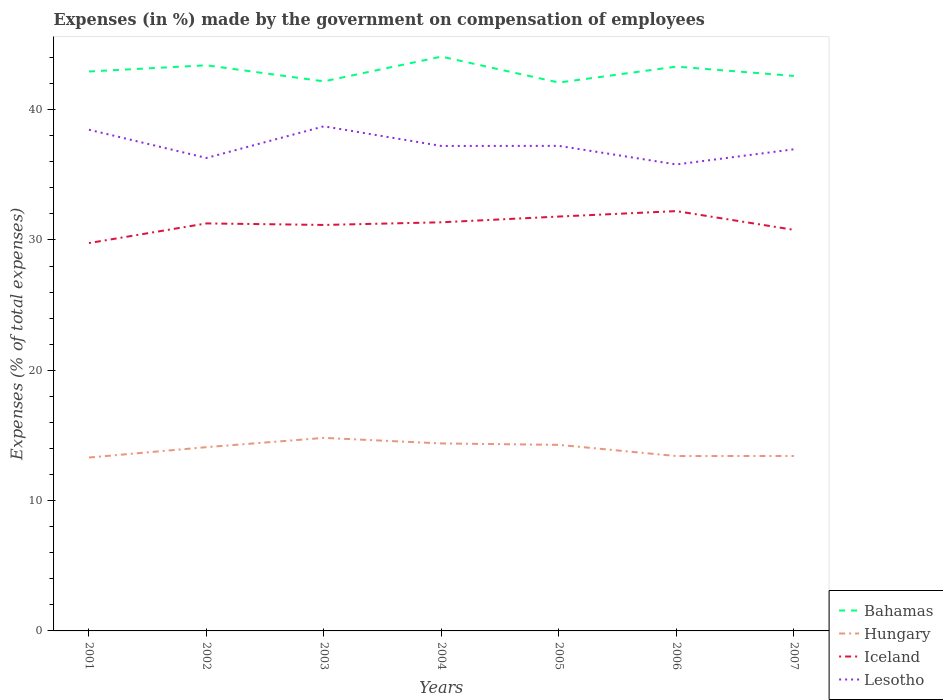Does the line corresponding to Bahamas intersect with the line corresponding to Hungary?
Provide a short and direct response. No. Across all years, what is the maximum percentage of expenses made by the government on compensation of employees in Lesotho?
Your answer should be very brief. 35.8. What is the total percentage of expenses made by the government on compensation of employees in Hungary in the graph?
Ensure brevity in your answer.  0.68. What is the difference between the highest and the second highest percentage of expenses made by the government on compensation of employees in Iceland?
Offer a very short reply. 2.45. What is the difference between the highest and the lowest percentage of expenses made by the government on compensation of employees in Lesotho?
Make the answer very short. 2. How many lines are there?
Provide a succinct answer. 4. How many years are there in the graph?
Your response must be concise. 7. What is the title of the graph?
Make the answer very short. Expenses (in %) made by the government on compensation of employees. Does "China" appear as one of the legend labels in the graph?
Make the answer very short. No. What is the label or title of the Y-axis?
Provide a succinct answer. Expenses (% of total expenses). What is the Expenses (% of total expenses) of Bahamas in 2001?
Provide a short and direct response. 42.93. What is the Expenses (% of total expenses) of Hungary in 2001?
Make the answer very short. 13.31. What is the Expenses (% of total expenses) in Iceland in 2001?
Ensure brevity in your answer.  29.76. What is the Expenses (% of total expenses) of Lesotho in 2001?
Your answer should be compact. 38.46. What is the Expenses (% of total expenses) of Bahamas in 2002?
Your response must be concise. 43.41. What is the Expenses (% of total expenses) in Hungary in 2002?
Keep it short and to the point. 14.1. What is the Expenses (% of total expenses) in Iceland in 2002?
Your answer should be compact. 31.27. What is the Expenses (% of total expenses) of Lesotho in 2002?
Your answer should be very brief. 36.29. What is the Expenses (% of total expenses) of Bahamas in 2003?
Give a very brief answer. 42.17. What is the Expenses (% of total expenses) of Hungary in 2003?
Give a very brief answer. 14.81. What is the Expenses (% of total expenses) of Iceland in 2003?
Give a very brief answer. 31.15. What is the Expenses (% of total expenses) of Lesotho in 2003?
Your answer should be very brief. 38.72. What is the Expenses (% of total expenses) of Bahamas in 2004?
Make the answer very short. 44.07. What is the Expenses (% of total expenses) in Hungary in 2004?
Your response must be concise. 14.39. What is the Expenses (% of total expenses) of Iceland in 2004?
Provide a short and direct response. 31.36. What is the Expenses (% of total expenses) in Lesotho in 2004?
Provide a succinct answer. 37.21. What is the Expenses (% of total expenses) in Bahamas in 2005?
Your response must be concise. 42.08. What is the Expenses (% of total expenses) of Hungary in 2005?
Keep it short and to the point. 14.28. What is the Expenses (% of total expenses) in Iceland in 2005?
Your response must be concise. 31.8. What is the Expenses (% of total expenses) of Lesotho in 2005?
Ensure brevity in your answer.  37.22. What is the Expenses (% of total expenses) of Bahamas in 2006?
Your answer should be very brief. 43.3. What is the Expenses (% of total expenses) in Hungary in 2006?
Your response must be concise. 13.42. What is the Expenses (% of total expenses) in Iceland in 2006?
Your answer should be very brief. 32.21. What is the Expenses (% of total expenses) in Lesotho in 2006?
Ensure brevity in your answer.  35.8. What is the Expenses (% of total expenses) in Bahamas in 2007?
Your answer should be very brief. 42.59. What is the Expenses (% of total expenses) in Hungary in 2007?
Provide a short and direct response. 13.43. What is the Expenses (% of total expenses) of Iceland in 2007?
Your answer should be very brief. 30.78. What is the Expenses (% of total expenses) in Lesotho in 2007?
Offer a very short reply. 36.96. Across all years, what is the maximum Expenses (% of total expenses) of Bahamas?
Offer a very short reply. 44.07. Across all years, what is the maximum Expenses (% of total expenses) in Hungary?
Your answer should be compact. 14.81. Across all years, what is the maximum Expenses (% of total expenses) in Iceland?
Your answer should be very brief. 32.21. Across all years, what is the maximum Expenses (% of total expenses) in Lesotho?
Your response must be concise. 38.72. Across all years, what is the minimum Expenses (% of total expenses) of Bahamas?
Your answer should be very brief. 42.08. Across all years, what is the minimum Expenses (% of total expenses) of Hungary?
Offer a very short reply. 13.31. Across all years, what is the minimum Expenses (% of total expenses) of Iceland?
Make the answer very short. 29.76. Across all years, what is the minimum Expenses (% of total expenses) of Lesotho?
Ensure brevity in your answer.  35.8. What is the total Expenses (% of total expenses) of Bahamas in the graph?
Ensure brevity in your answer.  300.55. What is the total Expenses (% of total expenses) in Hungary in the graph?
Provide a short and direct response. 97.73. What is the total Expenses (% of total expenses) in Iceland in the graph?
Ensure brevity in your answer.  218.34. What is the total Expenses (% of total expenses) of Lesotho in the graph?
Ensure brevity in your answer.  260.66. What is the difference between the Expenses (% of total expenses) of Bahamas in 2001 and that in 2002?
Make the answer very short. -0.48. What is the difference between the Expenses (% of total expenses) of Hungary in 2001 and that in 2002?
Provide a short and direct response. -0.8. What is the difference between the Expenses (% of total expenses) in Iceland in 2001 and that in 2002?
Provide a short and direct response. -1.51. What is the difference between the Expenses (% of total expenses) in Lesotho in 2001 and that in 2002?
Provide a succinct answer. 2.17. What is the difference between the Expenses (% of total expenses) of Bahamas in 2001 and that in 2003?
Make the answer very short. 0.76. What is the difference between the Expenses (% of total expenses) of Hungary in 2001 and that in 2003?
Your answer should be compact. -1.51. What is the difference between the Expenses (% of total expenses) of Iceland in 2001 and that in 2003?
Keep it short and to the point. -1.39. What is the difference between the Expenses (% of total expenses) of Lesotho in 2001 and that in 2003?
Make the answer very short. -0.26. What is the difference between the Expenses (% of total expenses) in Bahamas in 2001 and that in 2004?
Provide a succinct answer. -1.14. What is the difference between the Expenses (% of total expenses) in Hungary in 2001 and that in 2004?
Offer a very short reply. -1.08. What is the difference between the Expenses (% of total expenses) in Iceland in 2001 and that in 2004?
Your answer should be very brief. -1.59. What is the difference between the Expenses (% of total expenses) of Lesotho in 2001 and that in 2004?
Offer a terse response. 1.25. What is the difference between the Expenses (% of total expenses) in Bahamas in 2001 and that in 2005?
Keep it short and to the point. 0.85. What is the difference between the Expenses (% of total expenses) of Hungary in 2001 and that in 2005?
Keep it short and to the point. -0.97. What is the difference between the Expenses (% of total expenses) in Iceland in 2001 and that in 2005?
Ensure brevity in your answer.  -2.04. What is the difference between the Expenses (% of total expenses) of Lesotho in 2001 and that in 2005?
Make the answer very short. 1.24. What is the difference between the Expenses (% of total expenses) of Bahamas in 2001 and that in 2006?
Ensure brevity in your answer.  -0.37. What is the difference between the Expenses (% of total expenses) of Hungary in 2001 and that in 2006?
Make the answer very short. -0.11. What is the difference between the Expenses (% of total expenses) in Iceland in 2001 and that in 2006?
Keep it short and to the point. -2.45. What is the difference between the Expenses (% of total expenses) of Lesotho in 2001 and that in 2006?
Your answer should be compact. 2.67. What is the difference between the Expenses (% of total expenses) in Bahamas in 2001 and that in 2007?
Ensure brevity in your answer.  0.34. What is the difference between the Expenses (% of total expenses) of Hungary in 2001 and that in 2007?
Provide a succinct answer. -0.12. What is the difference between the Expenses (% of total expenses) in Iceland in 2001 and that in 2007?
Keep it short and to the point. -1.01. What is the difference between the Expenses (% of total expenses) of Lesotho in 2001 and that in 2007?
Keep it short and to the point. 1.5. What is the difference between the Expenses (% of total expenses) in Bahamas in 2002 and that in 2003?
Give a very brief answer. 1.23. What is the difference between the Expenses (% of total expenses) in Hungary in 2002 and that in 2003?
Offer a terse response. -0.71. What is the difference between the Expenses (% of total expenses) of Iceland in 2002 and that in 2003?
Offer a terse response. 0.12. What is the difference between the Expenses (% of total expenses) in Lesotho in 2002 and that in 2003?
Provide a succinct answer. -2.43. What is the difference between the Expenses (% of total expenses) of Bahamas in 2002 and that in 2004?
Your response must be concise. -0.66. What is the difference between the Expenses (% of total expenses) in Hungary in 2002 and that in 2004?
Offer a very short reply. -0.29. What is the difference between the Expenses (% of total expenses) of Iceland in 2002 and that in 2004?
Provide a succinct answer. -0.09. What is the difference between the Expenses (% of total expenses) in Lesotho in 2002 and that in 2004?
Make the answer very short. -0.92. What is the difference between the Expenses (% of total expenses) of Bahamas in 2002 and that in 2005?
Your answer should be very brief. 1.33. What is the difference between the Expenses (% of total expenses) of Hungary in 2002 and that in 2005?
Provide a short and direct response. -0.18. What is the difference between the Expenses (% of total expenses) in Iceland in 2002 and that in 2005?
Offer a very short reply. -0.53. What is the difference between the Expenses (% of total expenses) in Lesotho in 2002 and that in 2005?
Ensure brevity in your answer.  -0.93. What is the difference between the Expenses (% of total expenses) in Bahamas in 2002 and that in 2006?
Your response must be concise. 0.1. What is the difference between the Expenses (% of total expenses) in Hungary in 2002 and that in 2006?
Make the answer very short. 0.68. What is the difference between the Expenses (% of total expenses) in Iceland in 2002 and that in 2006?
Offer a very short reply. -0.94. What is the difference between the Expenses (% of total expenses) of Lesotho in 2002 and that in 2006?
Your response must be concise. 0.5. What is the difference between the Expenses (% of total expenses) of Bahamas in 2002 and that in 2007?
Your answer should be very brief. 0.82. What is the difference between the Expenses (% of total expenses) in Hungary in 2002 and that in 2007?
Your answer should be compact. 0.68. What is the difference between the Expenses (% of total expenses) in Iceland in 2002 and that in 2007?
Provide a short and direct response. 0.49. What is the difference between the Expenses (% of total expenses) of Lesotho in 2002 and that in 2007?
Ensure brevity in your answer.  -0.67. What is the difference between the Expenses (% of total expenses) in Bahamas in 2003 and that in 2004?
Your response must be concise. -1.9. What is the difference between the Expenses (% of total expenses) of Hungary in 2003 and that in 2004?
Your response must be concise. 0.43. What is the difference between the Expenses (% of total expenses) in Iceland in 2003 and that in 2004?
Make the answer very short. -0.2. What is the difference between the Expenses (% of total expenses) of Lesotho in 2003 and that in 2004?
Make the answer very short. 1.51. What is the difference between the Expenses (% of total expenses) of Bahamas in 2003 and that in 2005?
Your answer should be compact. 0.09. What is the difference between the Expenses (% of total expenses) of Hungary in 2003 and that in 2005?
Keep it short and to the point. 0.54. What is the difference between the Expenses (% of total expenses) in Iceland in 2003 and that in 2005?
Provide a short and direct response. -0.65. What is the difference between the Expenses (% of total expenses) in Lesotho in 2003 and that in 2005?
Make the answer very short. 1.5. What is the difference between the Expenses (% of total expenses) of Bahamas in 2003 and that in 2006?
Your response must be concise. -1.13. What is the difference between the Expenses (% of total expenses) in Hungary in 2003 and that in 2006?
Offer a very short reply. 1.4. What is the difference between the Expenses (% of total expenses) in Iceland in 2003 and that in 2006?
Make the answer very short. -1.06. What is the difference between the Expenses (% of total expenses) in Lesotho in 2003 and that in 2006?
Your response must be concise. 2.93. What is the difference between the Expenses (% of total expenses) of Bahamas in 2003 and that in 2007?
Give a very brief answer. -0.42. What is the difference between the Expenses (% of total expenses) of Hungary in 2003 and that in 2007?
Your answer should be compact. 1.39. What is the difference between the Expenses (% of total expenses) in Iceland in 2003 and that in 2007?
Offer a terse response. 0.38. What is the difference between the Expenses (% of total expenses) of Lesotho in 2003 and that in 2007?
Provide a short and direct response. 1.76. What is the difference between the Expenses (% of total expenses) of Bahamas in 2004 and that in 2005?
Provide a short and direct response. 1.99. What is the difference between the Expenses (% of total expenses) in Hungary in 2004 and that in 2005?
Offer a terse response. 0.11. What is the difference between the Expenses (% of total expenses) in Iceland in 2004 and that in 2005?
Provide a succinct answer. -0.44. What is the difference between the Expenses (% of total expenses) in Lesotho in 2004 and that in 2005?
Offer a terse response. -0.01. What is the difference between the Expenses (% of total expenses) of Bahamas in 2004 and that in 2006?
Your response must be concise. 0.77. What is the difference between the Expenses (% of total expenses) in Hungary in 2004 and that in 2006?
Make the answer very short. 0.97. What is the difference between the Expenses (% of total expenses) in Iceland in 2004 and that in 2006?
Keep it short and to the point. -0.86. What is the difference between the Expenses (% of total expenses) in Lesotho in 2004 and that in 2006?
Give a very brief answer. 1.42. What is the difference between the Expenses (% of total expenses) in Bahamas in 2004 and that in 2007?
Your answer should be very brief. 1.48. What is the difference between the Expenses (% of total expenses) in Hungary in 2004 and that in 2007?
Offer a terse response. 0.96. What is the difference between the Expenses (% of total expenses) in Iceland in 2004 and that in 2007?
Give a very brief answer. 0.58. What is the difference between the Expenses (% of total expenses) in Lesotho in 2004 and that in 2007?
Ensure brevity in your answer.  0.26. What is the difference between the Expenses (% of total expenses) of Bahamas in 2005 and that in 2006?
Offer a very short reply. -1.22. What is the difference between the Expenses (% of total expenses) of Hungary in 2005 and that in 2006?
Ensure brevity in your answer.  0.86. What is the difference between the Expenses (% of total expenses) in Iceland in 2005 and that in 2006?
Offer a very short reply. -0.42. What is the difference between the Expenses (% of total expenses) in Lesotho in 2005 and that in 2006?
Keep it short and to the point. 1.43. What is the difference between the Expenses (% of total expenses) in Bahamas in 2005 and that in 2007?
Your answer should be very brief. -0.51. What is the difference between the Expenses (% of total expenses) of Hungary in 2005 and that in 2007?
Provide a succinct answer. 0.85. What is the difference between the Expenses (% of total expenses) in Iceland in 2005 and that in 2007?
Provide a short and direct response. 1.02. What is the difference between the Expenses (% of total expenses) of Lesotho in 2005 and that in 2007?
Offer a terse response. 0.26. What is the difference between the Expenses (% of total expenses) of Bahamas in 2006 and that in 2007?
Provide a short and direct response. 0.72. What is the difference between the Expenses (% of total expenses) of Hungary in 2006 and that in 2007?
Your answer should be very brief. -0.01. What is the difference between the Expenses (% of total expenses) of Iceland in 2006 and that in 2007?
Keep it short and to the point. 1.44. What is the difference between the Expenses (% of total expenses) in Lesotho in 2006 and that in 2007?
Offer a terse response. -1.16. What is the difference between the Expenses (% of total expenses) of Bahamas in 2001 and the Expenses (% of total expenses) of Hungary in 2002?
Provide a succinct answer. 28.83. What is the difference between the Expenses (% of total expenses) in Bahamas in 2001 and the Expenses (% of total expenses) in Iceland in 2002?
Provide a short and direct response. 11.66. What is the difference between the Expenses (% of total expenses) of Bahamas in 2001 and the Expenses (% of total expenses) of Lesotho in 2002?
Offer a very short reply. 6.64. What is the difference between the Expenses (% of total expenses) of Hungary in 2001 and the Expenses (% of total expenses) of Iceland in 2002?
Offer a terse response. -17.97. What is the difference between the Expenses (% of total expenses) of Hungary in 2001 and the Expenses (% of total expenses) of Lesotho in 2002?
Make the answer very short. -22.99. What is the difference between the Expenses (% of total expenses) of Iceland in 2001 and the Expenses (% of total expenses) of Lesotho in 2002?
Your answer should be very brief. -6.53. What is the difference between the Expenses (% of total expenses) of Bahamas in 2001 and the Expenses (% of total expenses) of Hungary in 2003?
Your answer should be compact. 28.12. What is the difference between the Expenses (% of total expenses) of Bahamas in 2001 and the Expenses (% of total expenses) of Iceland in 2003?
Your response must be concise. 11.78. What is the difference between the Expenses (% of total expenses) of Bahamas in 2001 and the Expenses (% of total expenses) of Lesotho in 2003?
Provide a short and direct response. 4.21. What is the difference between the Expenses (% of total expenses) in Hungary in 2001 and the Expenses (% of total expenses) in Iceland in 2003?
Offer a very short reply. -17.85. What is the difference between the Expenses (% of total expenses) of Hungary in 2001 and the Expenses (% of total expenses) of Lesotho in 2003?
Offer a terse response. -25.42. What is the difference between the Expenses (% of total expenses) in Iceland in 2001 and the Expenses (% of total expenses) in Lesotho in 2003?
Provide a succinct answer. -8.96. What is the difference between the Expenses (% of total expenses) of Bahamas in 2001 and the Expenses (% of total expenses) of Hungary in 2004?
Give a very brief answer. 28.54. What is the difference between the Expenses (% of total expenses) in Bahamas in 2001 and the Expenses (% of total expenses) in Iceland in 2004?
Provide a succinct answer. 11.57. What is the difference between the Expenses (% of total expenses) in Bahamas in 2001 and the Expenses (% of total expenses) in Lesotho in 2004?
Keep it short and to the point. 5.72. What is the difference between the Expenses (% of total expenses) in Hungary in 2001 and the Expenses (% of total expenses) in Iceland in 2004?
Give a very brief answer. -18.05. What is the difference between the Expenses (% of total expenses) in Hungary in 2001 and the Expenses (% of total expenses) in Lesotho in 2004?
Keep it short and to the point. -23.91. What is the difference between the Expenses (% of total expenses) in Iceland in 2001 and the Expenses (% of total expenses) in Lesotho in 2004?
Your response must be concise. -7.45. What is the difference between the Expenses (% of total expenses) of Bahamas in 2001 and the Expenses (% of total expenses) of Hungary in 2005?
Your answer should be compact. 28.65. What is the difference between the Expenses (% of total expenses) of Bahamas in 2001 and the Expenses (% of total expenses) of Iceland in 2005?
Offer a very short reply. 11.13. What is the difference between the Expenses (% of total expenses) in Bahamas in 2001 and the Expenses (% of total expenses) in Lesotho in 2005?
Provide a short and direct response. 5.71. What is the difference between the Expenses (% of total expenses) of Hungary in 2001 and the Expenses (% of total expenses) of Iceland in 2005?
Keep it short and to the point. -18.49. What is the difference between the Expenses (% of total expenses) in Hungary in 2001 and the Expenses (% of total expenses) in Lesotho in 2005?
Offer a terse response. -23.92. What is the difference between the Expenses (% of total expenses) in Iceland in 2001 and the Expenses (% of total expenses) in Lesotho in 2005?
Ensure brevity in your answer.  -7.46. What is the difference between the Expenses (% of total expenses) of Bahamas in 2001 and the Expenses (% of total expenses) of Hungary in 2006?
Provide a succinct answer. 29.51. What is the difference between the Expenses (% of total expenses) in Bahamas in 2001 and the Expenses (% of total expenses) in Iceland in 2006?
Your answer should be compact. 10.72. What is the difference between the Expenses (% of total expenses) in Bahamas in 2001 and the Expenses (% of total expenses) in Lesotho in 2006?
Make the answer very short. 7.13. What is the difference between the Expenses (% of total expenses) of Hungary in 2001 and the Expenses (% of total expenses) of Iceland in 2006?
Ensure brevity in your answer.  -18.91. What is the difference between the Expenses (% of total expenses) in Hungary in 2001 and the Expenses (% of total expenses) in Lesotho in 2006?
Ensure brevity in your answer.  -22.49. What is the difference between the Expenses (% of total expenses) in Iceland in 2001 and the Expenses (% of total expenses) in Lesotho in 2006?
Your answer should be very brief. -6.03. What is the difference between the Expenses (% of total expenses) in Bahamas in 2001 and the Expenses (% of total expenses) in Hungary in 2007?
Provide a succinct answer. 29.5. What is the difference between the Expenses (% of total expenses) in Bahamas in 2001 and the Expenses (% of total expenses) in Iceland in 2007?
Make the answer very short. 12.15. What is the difference between the Expenses (% of total expenses) in Bahamas in 2001 and the Expenses (% of total expenses) in Lesotho in 2007?
Make the answer very short. 5.97. What is the difference between the Expenses (% of total expenses) in Hungary in 2001 and the Expenses (% of total expenses) in Iceland in 2007?
Give a very brief answer. -17.47. What is the difference between the Expenses (% of total expenses) of Hungary in 2001 and the Expenses (% of total expenses) of Lesotho in 2007?
Provide a succinct answer. -23.65. What is the difference between the Expenses (% of total expenses) in Iceland in 2001 and the Expenses (% of total expenses) in Lesotho in 2007?
Your response must be concise. -7.2. What is the difference between the Expenses (% of total expenses) of Bahamas in 2002 and the Expenses (% of total expenses) of Hungary in 2003?
Make the answer very short. 28.59. What is the difference between the Expenses (% of total expenses) of Bahamas in 2002 and the Expenses (% of total expenses) of Iceland in 2003?
Keep it short and to the point. 12.25. What is the difference between the Expenses (% of total expenses) in Bahamas in 2002 and the Expenses (% of total expenses) in Lesotho in 2003?
Your answer should be compact. 4.68. What is the difference between the Expenses (% of total expenses) in Hungary in 2002 and the Expenses (% of total expenses) in Iceland in 2003?
Your answer should be compact. -17.05. What is the difference between the Expenses (% of total expenses) of Hungary in 2002 and the Expenses (% of total expenses) of Lesotho in 2003?
Provide a succinct answer. -24.62. What is the difference between the Expenses (% of total expenses) in Iceland in 2002 and the Expenses (% of total expenses) in Lesotho in 2003?
Your answer should be compact. -7.45. What is the difference between the Expenses (% of total expenses) of Bahamas in 2002 and the Expenses (% of total expenses) of Hungary in 2004?
Offer a terse response. 29.02. What is the difference between the Expenses (% of total expenses) of Bahamas in 2002 and the Expenses (% of total expenses) of Iceland in 2004?
Offer a very short reply. 12.05. What is the difference between the Expenses (% of total expenses) of Bahamas in 2002 and the Expenses (% of total expenses) of Lesotho in 2004?
Your answer should be very brief. 6.19. What is the difference between the Expenses (% of total expenses) in Hungary in 2002 and the Expenses (% of total expenses) in Iceland in 2004?
Give a very brief answer. -17.26. What is the difference between the Expenses (% of total expenses) in Hungary in 2002 and the Expenses (% of total expenses) in Lesotho in 2004?
Your answer should be very brief. -23.11. What is the difference between the Expenses (% of total expenses) in Iceland in 2002 and the Expenses (% of total expenses) in Lesotho in 2004?
Provide a short and direct response. -5.94. What is the difference between the Expenses (% of total expenses) in Bahamas in 2002 and the Expenses (% of total expenses) in Hungary in 2005?
Make the answer very short. 29.13. What is the difference between the Expenses (% of total expenses) in Bahamas in 2002 and the Expenses (% of total expenses) in Iceland in 2005?
Your answer should be very brief. 11.61. What is the difference between the Expenses (% of total expenses) of Bahamas in 2002 and the Expenses (% of total expenses) of Lesotho in 2005?
Provide a succinct answer. 6.18. What is the difference between the Expenses (% of total expenses) in Hungary in 2002 and the Expenses (% of total expenses) in Iceland in 2005?
Your answer should be very brief. -17.7. What is the difference between the Expenses (% of total expenses) in Hungary in 2002 and the Expenses (% of total expenses) in Lesotho in 2005?
Give a very brief answer. -23.12. What is the difference between the Expenses (% of total expenses) of Iceland in 2002 and the Expenses (% of total expenses) of Lesotho in 2005?
Make the answer very short. -5.95. What is the difference between the Expenses (% of total expenses) of Bahamas in 2002 and the Expenses (% of total expenses) of Hungary in 2006?
Offer a terse response. 29.99. What is the difference between the Expenses (% of total expenses) of Bahamas in 2002 and the Expenses (% of total expenses) of Iceland in 2006?
Your answer should be very brief. 11.19. What is the difference between the Expenses (% of total expenses) of Bahamas in 2002 and the Expenses (% of total expenses) of Lesotho in 2006?
Give a very brief answer. 7.61. What is the difference between the Expenses (% of total expenses) in Hungary in 2002 and the Expenses (% of total expenses) in Iceland in 2006?
Provide a succinct answer. -18.11. What is the difference between the Expenses (% of total expenses) in Hungary in 2002 and the Expenses (% of total expenses) in Lesotho in 2006?
Provide a short and direct response. -21.69. What is the difference between the Expenses (% of total expenses) of Iceland in 2002 and the Expenses (% of total expenses) of Lesotho in 2006?
Ensure brevity in your answer.  -4.52. What is the difference between the Expenses (% of total expenses) in Bahamas in 2002 and the Expenses (% of total expenses) in Hungary in 2007?
Your response must be concise. 29.98. What is the difference between the Expenses (% of total expenses) of Bahamas in 2002 and the Expenses (% of total expenses) of Iceland in 2007?
Provide a succinct answer. 12.63. What is the difference between the Expenses (% of total expenses) of Bahamas in 2002 and the Expenses (% of total expenses) of Lesotho in 2007?
Make the answer very short. 6.45. What is the difference between the Expenses (% of total expenses) of Hungary in 2002 and the Expenses (% of total expenses) of Iceland in 2007?
Offer a very short reply. -16.68. What is the difference between the Expenses (% of total expenses) in Hungary in 2002 and the Expenses (% of total expenses) in Lesotho in 2007?
Give a very brief answer. -22.86. What is the difference between the Expenses (% of total expenses) of Iceland in 2002 and the Expenses (% of total expenses) of Lesotho in 2007?
Provide a short and direct response. -5.69. What is the difference between the Expenses (% of total expenses) in Bahamas in 2003 and the Expenses (% of total expenses) in Hungary in 2004?
Your answer should be very brief. 27.79. What is the difference between the Expenses (% of total expenses) of Bahamas in 2003 and the Expenses (% of total expenses) of Iceland in 2004?
Your answer should be compact. 10.82. What is the difference between the Expenses (% of total expenses) in Bahamas in 2003 and the Expenses (% of total expenses) in Lesotho in 2004?
Your answer should be very brief. 4.96. What is the difference between the Expenses (% of total expenses) of Hungary in 2003 and the Expenses (% of total expenses) of Iceland in 2004?
Offer a very short reply. -16.54. What is the difference between the Expenses (% of total expenses) in Hungary in 2003 and the Expenses (% of total expenses) in Lesotho in 2004?
Ensure brevity in your answer.  -22.4. What is the difference between the Expenses (% of total expenses) in Iceland in 2003 and the Expenses (% of total expenses) in Lesotho in 2004?
Provide a succinct answer. -6.06. What is the difference between the Expenses (% of total expenses) of Bahamas in 2003 and the Expenses (% of total expenses) of Hungary in 2005?
Ensure brevity in your answer.  27.89. What is the difference between the Expenses (% of total expenses) in Bahamas in 2003 and the Expenses (% of total expenses) in Iceland in 2005?
Your answer should be compact. 10.37. What is the difference between the Expenses (% of total expenses) of Bahamas in 2003 and the Expenses (% of total expenses) of Lesotho in 2005?
Offer a very short reply. 4.95. What is the difference between the Expenses (% of total expenses) of Hungary in 2003 and the Expenses (% of total expenses) of Iceland in 2005?
Your response must be concise. -16.98. What is the difference between the Expenses (% of total expenses) of Hungary in 2003 and the Expenses (% of total expenses) of Lesotho in 2005?
Offer a very short reply. -22.41. What is the difference between the Expenses (% of total expenses) of Iceland in 2003 and the Expenses (% of total expenses) of Lesotho in 2005?
Make the answer very short. -6.07. What is the difference between the Expenses (% of total expenses) in Bahamas in 2003 and the Expenses (% of total expenses) in Hungary in 2006?
Provide a short and direct response. 28.75. What is the difference between the Expenses (% of total expenses) of Bahamas in 2003 and the Expenses (% of total expenses) of Iceland in 2006?
Give a very brief answer. 9.96. What is the difference between the Expenses (% of total expenses) in Bahamas in 2003 and the Expenses (% of total expenses) in Lesotho in 2006?
Keep it short and to the point. 6.38. What is the difference between the Expenses (% of total expenses) in Hungary in 2003 and the Expenses (% of total expenses) in Iceland in 2006?
Give a very brief answer. -17.4. What is the difference between the Expenses (% of total expenses) in Hungary in 2003 and the Expenses (% of total expenses) in Lesotho in 2006?
Your response must be concise. -20.98. What is the difference between the Expenses (% of total expenses) in Iceland in 2003 and the Expenses (% of total expenses) in Lesotho in 2006?
Your answer should be very brief. -4.64. What is the difference between the Expenses (% of total expenses) of Bahamas in 2003 and the Expenses (% of total expenses) of Hungary in 2007?
Provide a succinct answer. 28.75. What is the difference between the Expenses (% of total expenses) in Bahamas in 2003 and the Expenses (% of total expenses) in Iceland in 2007?
Provide a succinct answer. 11.39. What is the difference between the Expenses (% of total expenses) of Bahamas in 2003 and the Expenses (% of total expenses) of Lesotho in 2007?
Offer a terse response. 5.21. What is the difference between the Expenses (% of total expenses) of Hungary in 2003 and the Expenses (% of total expenses) of Iceland in 2007?
Ensure brevity in your answer.  -15.96. What is the difference between the Expenses (% of total expenses) of Hungary in 2003 and the Expenses (% of total expenses) of Lesotho in 2007?
Keep it short and to the point. -22.14. What is the difference between the Expenses (% of total expenses) of Iceland in 2003 and the Expenses (% of total expenses) of Lesotho in 2007?
Provide a succinct answer. -5.8. What is the difference between the Expenses (% of total expenses) of Bahamas in 2004 and the Expenses (% of total expenses) of Hungary in 2005?
Provide a short and direct response. 29.79. What is the difference between the Expenses (% of total expenses) in Bahamas in 2004 and the Expenses (% of total expenses) in Iceland in 2005?
Give a very brief answer. 12.27. What is the difference between the Expenses (% of total expenses) in Bahamas in 2004 and the Expenses (% of total expenses) in Lesotho in 2005?
Offer a very short reply. 6.85. What is the difference between the Expenses (% of total expenses) in Hungary in 2004 and the Expenses (% of total expenses) in Iceland in 2005?
Keep it short and to the point. -17.41. What is the difference between the Expenses (% of total expenses) of Hungary in 2004 and the Expenses (% of total expenses) of Lesotho in 2005?
Keep it short and to the point. -22.83. What is the difference between the Expenses (% of total expenses) of Iceland in 2004 and the Expenses (% of total expenses) of Lesotho in 2005?
Give a very brief answer. -5.86. What is the difference between the Expenses (% of total expenses) in Bahamas in 2004 and the Expenses (% of total expenses) in Hungary in 2006?
Your answer should be compact. 30.65. What is the difference between the Expenses (% of total expenses) of Bahamas in 2004 and the Expenses (% of total expenses) of Iceland in 2006?
Make the answer very short. 11.86. What is the difference between the Expenses (% of total expenses) of Bahamas in 2004 and the Expenses (% of total expenses) of Lesotho in 2006?
Give a very brief answer. 8.28. What is the difference between the Expenses (% of total expenses) of Hungary in 2004 and the Expenses (% of total expenses) of Iceland in 2006?
Provide a succinct answer. -17.83. What is the difference between the Expenses (% of total expenses) in Hungary in 2004 and the Expenses (% of total expenses) in Lesotho in 2006?
Your answer should be very brief. -21.41. What is the difference between the Expenses (% of total expenses) in Iceland in 2004 and the Expenses (% of total expenses) in Lesotho in 2006?
Offer a very short reply. -4.44. What is the difference between the Expenses (% of total expenses) of Bahamas in 2004 and the Expenses (% of total expenses) of Hungary in 2007?
Your response must be concise. 30.64. What is the difference between the Expenses (% of total expenses) of Bahamas in 2004 and the Expenses (% of total expenses) of Iceland in 2007?
Your answer should be very brief. 13.29. What is the difference between the Expenses (% of total expenses) of Bahamas in 2004 and the Expenses (% of total expenses) of Lesotho in 2007?
Make the answer very short. 7.11. What is the difference between the Expenses (% of total expenses) in Hungary in 2004 and the Expenses (% of total expenses) in Iceland in 2007?
Offer a very short reply. -16.39. What is the difference between the Expenses (% of total expenses) of Hungary in 2004 and the Expenses (% of total expenses) of Lesotho in 2007?
Offer a very short reply. -22.57. What is the difference between the Expenses (% of total expenses) of Iceland in 2004 and the Expenses (% of total expenses) of Lesotho in 2007?
Ensure brevity in your answer.  -5.6. What is the difference between the Expenses (% of total expenses) of Bahamas in 2005 and the Expenses (% of total expenses) of Hungary in 2006?
Make the answer very short. 28.66. What is the difference between the Expenses (% of total expenses) in Bahamas in 2005 and the Expenses (% of total expenses) in Iceland in 2006?
Keep it short and to the point. 9.87. What is the difference between the Expenses (% of total expenses) of Bahamas in 2005 and the Expenses (% of total expenses) of Lesotho in 2006?
Keep it short and to the point. 6.28. What is the difference between the Expenses (% of total expenses) in Hungary in 2005 and the Expenses (% of total expenses) in Iceland in 2006?
Give a very brief answer. -17.94. What is the difference between the Expenses (% of total expenses) in Hungary in 2005 and the Expenses (% of total expenses) in Lesotho in 2006?
Keep it short and to the point. -21.52. What is the difference between the Expenses (% of total expenses) in Iceland in 2005 and the Expenses (% of total expenses) in Lesotho in 2006?
Your answer should be very brief. -4. What is the difference between the Expenses (% of total expenses) of Bahamas in 2005 and the Expenses (% of total expenses) of Hungary in 2007?
Your answer should be compact. 28.65. What is the difference between the Expenses (% of total expenses) of Bahamas in 2005 and the Expenses (% of total expenses) of Iceland in 2007?
Make the answer very short. 11.3. What is the difference between the Expenses (% of total expenses) of Bahamas in 2005 and the Expenses (% of total expenses) of Lesotho in 2007?
Your answer should be very brief. 5.12. What is the difference between the Expenses (% of total expenses) of Hungary in 2005 and the Expenses (% of total expenses) of Iceland in 2007?
Keep it short and to the point. -16.5. What is the difference between the Expenses (% of total expenses) in Hungary in 2005 and the Expenses (% of total expenses) in Lesotho in 2007?
Your answer should be compact. -22.68. What is the difference between the Expenses (% of total expenses) of Iceland in 2005 and the Expenses (% of total expenses) of Lesotho in 2007?
Offer a very short reply. -5.16. What is the difference between the Expenses (% of total expenses) of Bahamas in 2006 and the Expenses (% of total expenses) of Hungary in 2007?
Ensure brevity in your answer.  29.88. What is the difference between the Expenses (% of total expenses) in Bahamas in 2006 and the Expenses (% of total expenses) in Iceland in 2007?
Provide a succinct answer. 12.53. What is the difference between the Expenses (% of total expenses) of Bahamas in 2006 and the Expenses (% of total expenses) of Lesotho in 2007?
Provide a short and direct response. 6.34. What is the difference between the Expenses (% of total expenses) in Hungary in 2006 and the Expenses (% of total expenses) in Iceland in 2007?
Your response must be concise. -17.36. What is the difference between the Expenses (% of total expenses) of Hungary in 2006 and the Expenses (% of total expenses) of Lesotho in 2007?
Offer a terse response. -23.54. What is the difference between the Expenses (% of total expenses) of Iceland in 2006 and the Expenses (% of total expenses) of Lesotho in 2007?
Offer a terse response. -4.74. What is the average Expenses (% of total expenses) in Bahamas per year?
Keep it short and to the point. 42.94. What is the average Expenses (% of total expenses) in Hungary per year?
Your answer should be very brief. 13.96. What is the average Expenses (% of total expenses) in Iceland per year?
Give a very brief answer. 31.19. What is the average Expenses (% of total expenses) in Lesotho per year?
Your answer should be very brief. 37.24. In the year 2001, what is the difference between the Expenses (% of total expenses) of Bahamas and Expenses (% of total expenses) of Hungary?
Keep it short and to the point. 29.62. In the year 2001, what is the difference between the Expenses (% of total expenses) in Bahamas and Expenses (% of total expenses) in Iceland?
Offer a terse response. 13.17. In the year 2001, what is the difference between the Expenses (% of total expenses) in Bahamas and Expenses (% of total expenses) in Lesotho?
Make the answer very short. 4.47. In the year 2001, what is the difference between the Expenses (% of total expenses) in Hungary and Expenses (% of total expenses) in Iceland?
Give a very brief answer. -16.46. In the year 2001, what is the difference between the Expenses (% of total expenses) of Hungary and Expenses (% of total expenses) of Lesotho?
Make the answer very short. -25.15. In the year 2001, what is the difference between the Expenses (% of total expenses) of Iceland and Expenses (% of total expenses) of Lesotho?
Make the answer very short. -8.7. In the year 2002, what is the difference between the Expenses (% of total expenses) in Bahamas and Expenses (% of total expenses) in Hungary?
Offer a terse response. 29.3. In the year 2002, what is the difference between the Expenses (% of total expenses) in Bahamas and Expenses (% of total expenses) in Iceland?
Provide a succinct answer. 12.13. In the year 2002, what is the difference between the Expenses (% of total expenses) of Bahamas and Expenses (% of total expenses) of Lesotho?
Your answer should be compact. 7.11. In the year 2002, what is the difference between the Expenses (% of total expenses) in Hungary and Expenses (% of total expenses) in Iceland?
Provide a succinct answer. -17.17. In the year 2002, what is the difference between the Expenses (% of total expenses) of Hungary and Expenses (% of total expenses) of Lesotho?
Give a very brief answer. -22.19. In the year 2002, what is the difference between the Expenses (% of total expenses) of Iceland and Expenses (% of total expenses) of Lesotho?
Your answer should be very brief. -5.02. In the year 2003, what is the difference between the Expenses (% of total expenses) in Bahamas and Expenses (% of total expenses) in Hungary?
Ensure brevity in your answer.  27.36. In the year 2003, what is the difference between the Expenses (% of total expenses) of Bahamas and Expenses (% of total expenses) of Iceland?
Make the answer very short. 11.02. In the year 2003, what is the difference between the Expenses (% of total expenses) in Bahamas and Expenses (% of total expenses) in Lesotho?
Provide a short and direct response. 3.45. In the year 2003, what is the difference between the Expenses (% of total expenses) of Hungary and Expenses (% of total expenses) of Iceland?
Your answer should be compact. -16.34. In the year 2003, what is the difference between the Expenses (% of total expenses) of Hungary and Expenses (% of total expenses) of Lesotho?
Keep it short and to the point. -23.91. In the year 2003, what is the difference between the Expenses (% of total expenses) of Iceland and Expenses (% of total expenses) of Lesotho?
Give a very brief answer. -7.57. In the year 2004, what is the difference between the Expenses (% of total expenses) in Bahamas and Expenses (% of total expenses) in Hungary?
Ensure brevity in your answer.  29.68. In the year 2004, what is the difference between the Expenses (% of total expenses) of Bahamas and Expenses (% of total expenses) of Iceland?
Make the answer very short. 12.71. In the year 2004, what is the difference between the Expenses (% of total expenses) in Bahamas and Expenses (% of total expenses) in Lesotho?
Provide a succinct answer. 6.86. In the year 2004, what is the difference between the Expenses (% of total expenses) of Hungary and Expenses (% of total expenses) of Iceland?
Give a very brief answer. -16.97. In the year 2004, what is the difference between the Expenses (% of total expenses) of Hungary and Expenses (% of total expenses) of Lesotho?
Your response must be concise. -22.83. In the year 2004, what is the difference between the Expenses (% of total expenses) in Iceland and Expenses (% of total expenses) in Lesotho?
Keep it short and to the point. -5.86. In the year 2005, what is the difference between the Expenses (% of total expenses) of Bahamas and Expenses (% of total expenses) of Hungary?
Offer a terse response. 27.8. In the year 2005, what is the difference between the Expenses (% of total expenses) of Bahamas and Expenses (% of total expenses) of Iceland?
Provide a short and direct response. 10.28. In the year 2005, what is the difference between the Expenses (% of total expenses) in Bahamas and Expenses (% of total expenses) in Lesotho?
Your answer should be compact. 4.86. In the year 2005, what is the difference between the Expenses (% of total expenses) in Hungary and Expenses (% of total expenses) in Iceland?
Make the answer very short. -17.52. In the year 2005, what is the difference between the Expenses (% of total expenses) of Hungary and Expenses (% of total expenses) of Lesotho?
Offer a very short reply. -22.94. In the year 2005, what is the difference between the Expenses (% of total expenses) of Iceland and Expenses (% of total expenses) of Lesotho?
Offer a very short reply. -5.42. In the year 2006, what is the difference between the Expenses (% of total expenses) of Bahamas and Expenses (% of total expenses) of Hungary?
Your answer should be very brief. 29.88. In the year 2006, what is the difference between the Expenses (% of total expenses) in Bahamas and Expenses (% of total expenses) in Iceland?
Make the answer very short. 11.09. In the year 2006, what is the difference between the Expenses (% of total expenses) of Bahamas and Expenses (% of total expenses) of Lesotho?
Your response must be concise. 7.51. In the year 2006, what is the difference between the Expenses (% of total expenses) in Hungary and Expenses (% of total expenses) in Iceland?
Ensure brevity in your answer.  -18.8. In the year 2006, what is the difference between the Expenses (% of total expenses) of Hungary and Expenses (% of total expenses) of Lesotho?
Keep it short and to the point. -22.38. In the year 2006, what is the difference between the Expenses (% of total expenses) in Iceland and Expenses (% of total expenses) in Lesotho?
Offer a very short reply. -3.58. In the year 2007, what is the difference between the Expenses (% of total expenses) in Bahamas and Expenses (% of total expenses) in Hungary?
Keep it short and to the point. 29.16. In the year 2007, what is the difference between the Expenses (% of total expenses) in Bahamas and Expenses (% of total expenses) in Iceland?
Keep it short and to the point. 11.81. In the year 2007, what is the difference between the Expenses (% of total expenses) in Bahamas and Expenses (% of total expenses) in Lesotho?
Offer a very short reply. 5.63. In the year 2007, what is the difference between the Expenses (% of total expenses) of Hungary and Expenses (% of total expenses) of Iceland?
Ensure brevity in your answer.  -17.35. In the year 2007, what is the difference between the Expenses (% of total expenses) of Hungary and Expenses (% of total expenses) of Lesotho?
Your response must be concise. -23.53. In the year 2007, what is the difference between the Expenses (% of total expenses) of Iceland and Expenses (% of total expenses) of Lesotho?
Provide a succinct answer. -6.18. What is the ratio of the Expenses (% of total expenses) in Bahamas in 2001 to that in 2002?
Your response must be concise. 0.99. What is the ratio of the Expenses (% of total expenses) of Hungary in 2001 to that in 2002?
Offer a terse response. 0.94. What is the ratio of the Expenses (% of total expenses) in Iceland in 2001 to that in 2002?
Offer a very short reply. 0.95. What is the ratio of the Expenses (% of total expenses) in Lesotho in 2001 to that in 2002?
Provide a succinct answer. 1.06. What is the ratio of the Expenses (% of total expenses) in Hungary in 2001 to that in 2003?
Your response must be concise. 0.9. What is the ratio of the Expenses (% of total expenses) of Iceland in 2001 to that in 2003?
Offer a terse response. 0.96. What is the ratio of the Expenses (% of total expenses) in Bahamas in 2001 to that in 2004?
Make the answer very short. 0.97. What is the ratio of the Expenses (% of total expenses) in Hungary in 2001 to that in 2004?
Keep it short and to the point. 0.92. What is the ratio of the Expenses (% of total expenses) in Iceland in 2001 to that in 2004?
Provide a succinct answer. 0.95. What is the ratio of the Expenses (% of total expenses) in Lesotho in 2001 to that in 2004?
Make the answer very short. 1.03. What is the ratio of the Expenses (% of total expenses) in Bahamas in 2001 to that in 2005?
Offer a very short reply. 1.02. What is the ratio of the Expenses (% of total expenses) in Hungary in 2001 to that in 2005?
Keep it short and to the point. 0.93. What is the ratio of the Expenses (% of total expenses) of Iceland in 2001 to that in 2005?
Offer a terse response. 0.94. What is the ratio of the Expenses (% of total expenses) in Hungary in 2001 to that in 2006?
Give a very brief answer. 0.99. What is the ratio of the Expenses (% of total expenses) in Iceland in 2001 to that in 2006?
Offer a terse response. 0.92. What is the ratio of the Expenses (% of total expenses) in Lesotho in 2001 to that in 2006?
Your answer should be very brief. 1.07. What is the ratio of the Expenses (% of total expenses) of Bahamas in 2001 to that in 2007?
Provide a succinct answer. 1.01. What is the ratio of the Expenses (% of total expenses) of Lesotho in 2001 to that in 2007?
Your response must be concise. 1.04. What is the ratio of the Expenses (% of total expenses) of Bahamas in 2002 to that in 2003?
Offer a very short reply. 1.03. What is the ratio of the Expenses (% of total expenses) in Hungary in 2002 to that in 2003?
Your response must be concise. 0.95. What is the ratio of the Expenses (% of total expenses) in Lesotho in 2002 to that in 2003?
Your answer should be compact. 0.94. What is the ratio of the Expenses (% of total expenses) of Bahamas in 2002 to that in 2004?
Provide a short and direct response. 0.98. What is the ratio of the Expenses (% of total expenses) in Hungary in 2002 to that in 2004?
Ensure brevity in your answer.  0.98. What is the ratio of the Expenses (% of total expenses) in Lesotho in 2002 to that in 2004?
Make the answer very short. 0.98. What is the ratio of the Expenses (% of total expenses) in Bahamas in 2002 to that in 2005?
Keep it short and to the point. 1.03. What is the ratio of the Expenses (% of total expenses) of Iceland in 2002 to that in 2005?
Give a very brief answer. 0.98. What is the ratio of the Expenses (% of total expenses) in Lesotho in 2002 to that in 2005?
Provide a short and direct response. 0.98. What is the ratio of the Expenses (% of total expenses) of Bahamas in 2002 to that in 2006?
Offer a very short reply. 1. What is the ratio of the Expenses (% of total expenses) of Hungary in 2002 to that in 2006?
Offer a terse response. 1.05. What is the ratio of the Expenses (% of total expenses) in Iceland in 2002 to that in 2006?
Give a very brief answer. 0.97. What is the ratio of the Expenses (% of total expenses) of Lesotho in 2002 to that in 2006?
Offer a very short reply. 1.01. What is the ratio of the Expenses (% of total expenses) of Bahamas in 2002 to that in 2007?
Provide a succinct answer. 1.02. What is the ratio of the Expenses (% of total expenses) of Hungary in 2002 to that in 2007?
Give a very brief answer. 1.05. What is the ratio of the Expenses (% of total expenses) in Bahamas in 2003 to that in 2004?
Make the answer very short. 0.96. What is the ratio of the Expenses (% of total expenses) in Hungary in 2003 to that in 2004?
Provide a succinct answer. 1.03. What is the ratio of the Expenses (% of total expenses) in Iceland in 2003 to that in 2004?
Provide a short and direct response. 0.99. What is the ratio of the Expenses (% of total expenses) of Lesotho in 2003 to that in 2004?
Offer a terse response. 1.04. What is the ratio of the Expenses (% of total expenses) in Hungary in 2003 to that in 2005?
Your answer should be very brief. 1.04. What is the ratio of the Expenses (% of total expenses) of Iceland in 2003 to that in 2005?
Keep it short and to the point. 0.98. What is the ratio of the Expenses (% of total expenses) of Lesotho in 2003 to that in 2005?
Your answer should be very brief. 1.04. What is the ratio of the Expenses (% of total expenses) in Bahamas in 2003 to that in 2006?
Give a very brief answer. 0.97. What is the ratio of the Expenses (% of total expenses) of Hungary in 2003 to that in 2006?
Keep it short and to the point. 1.1. What is the ratio of the Expenses (% of total expenses) in Iceland in 2003 to that in 2006?
Keep it short and to the point. 0.97. What is the ratio of the Expenses (% of total expenses) in Lesotho in 2003 to that in 2006?
Keep it short and to the point. 1.08. What is the ratio of the Expenses (% of total expenses) in Bahamas in 2003 to that in 2007?
Keep it short and to the point. 0.99. What is the ratio of the Expenses (% of total expenses) in Hungary in 2003 to that in 2007?
Your answer should be compact. 1.1. What is the ratio of the Expenses (% of total expenses) in Iceland in 2003 to that in 2007?
Offer a terse response. 1.01. What is the ratio of the Expenses (% of total expenses) in Lesotho in 2003 to that in 2007?
Your answer should be very brief. 1.05. What is the ratio of the Expenses (% of total expenses) in Bahamas in 2004 to that in 2005?
Your response must be concise. 1.05. What is the ratio of the Expenses (% of total expenses) in Hungary in 2004 to that in 2005?
Provide a short and direct response. 1.01. What is the ratio of the Expenses (% of total expenses) in Iceland in 2004 to that in 2005?
Ensure brevity in your answer.  0.99. What is the ratio of the Expenses (% of total expenses) of Lesotho in 2004 to that in 2005?
Give a very brief answer. 1. What is the ratio of the Expenses (% of total expenses) in Bahamas in 2004 to that in 2006?
Your response must be concise. 1.02. What is the ratio of the Expenses (% of total expenses) in Hungary in 2004 to that in 2006?
Ensure brevity in your answer.  1.07. What is the ratio of the Expenses (% of total expenses) of Iceland in 2004 to that in 2006?
Offer a very short reply. 0.97. What is the ratio of the Expenses (% of total expenses) of Lesotho in 2004 to that in 2006?
Keep it short and to the point. 1.04. What is the ratio of the Expenses (% of total expenses) in Bahamas in 2004 to that in 2007?
Your answer should be very brief. 1.03. What is the ratio of the Expenses (% of total expenses) of Hungary in 2004 to that in 2007?
Your response must be concise. 1.07. What is the ratio of the Expenses (% of total expenses) in Iceland in 2004 to that in 2007?
Keep it short and to the point. 1.02. What is the ratio of the Expenses (% of total expenses) of Lesotho in 2004 to that in 2007?
Keep it short and to the point. 1.01. What is the ratio of the Expenses (% of total expenses) of Bahamas in 2005 to that in 2006?
Keep it short and to the point. 0.97. What is the ratio of the Expenses (% of total expenses) of Hungary in 2005 to that in 2006?
Your answer should be very brief. 1.06. What is the ratio of the Expenses (% of total expenses) in Iceland in 2005 to that in 2006?
Ensure brevity in your answer.  0.99. What is the ratio of the Expenses (% of total expenses) in Lesotho in 2005 to that in 2006?
Your response must be concise. 1.04. What is the ratio of the Expenses (% of total expenses) of Hungary in 2005 to that in 2007?
Make the answer very short. 1.06. What is the ratio of the Expenses (% of total expenses) in Iceland in 2005 to that in 2007?
Your answer should be compact. 1.03. What is the ratio of the Expenses (% of total expenses) of Lesotho in 2005 to that in 2007?
Your answer should be very brief. 1.01. What is the ratio of the Expenses (% of total expenses) of Bahamas in 2006 to that in 2007?
Make the answer very short. 1.02. What is the ratio of the Expenses (% of total expenses) in Iceland in 2006 to that in 2007?
Provide a succinct answer. 1.05. What is the ratio of the Expenses (% of total expenses) in Lesotho in 2006 to that in 2007?
Ensure brevity in your answer.  0.97. What is the difference between the highest and the second highest Expenses (% of total expenses) of Bahamas?
Keep it short and to the point. 0.66. What is the difference between the highest and the second highest Expenses (% of total expenses) in Hungary?
Your response must be concise. 0.43. What is the difference between the highest and the second highest Expenses (% of total expenses) of Iceland?
Your answer should be very brief. 0.42. What is the difference between the highest and the second highest Expenses (% of total expenses) in Lesotho?
Offer a very short reply. 0.26. What is the difference between the highest and the lowest Expenses (% of total expenses) in Bahamas?
Offer a very short reply. 1.99. What is the difference between the highest and the lowest Expenses (% of total expenses) of Hungary?
Provide a short and direct response. 1.51. What is the difference between the highest and the lowest Expenses (% of total expenses) of Iceland?
Give a very brief answer. 2.45. What is the difference between the highest and the lowest Expenses (% of total expenses) in Lesotho?
Your answer should be very brief. 2.93. 